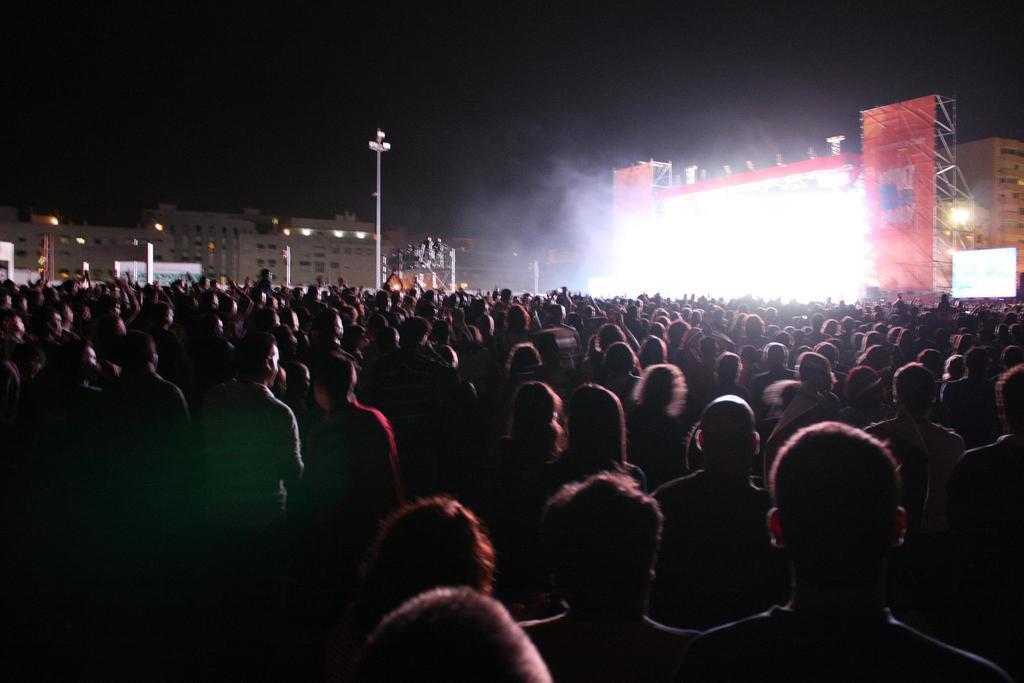Please provide a concise description of this image. We can see group of people. In the background we can see buildings,stage,smoke and lights on pole. 